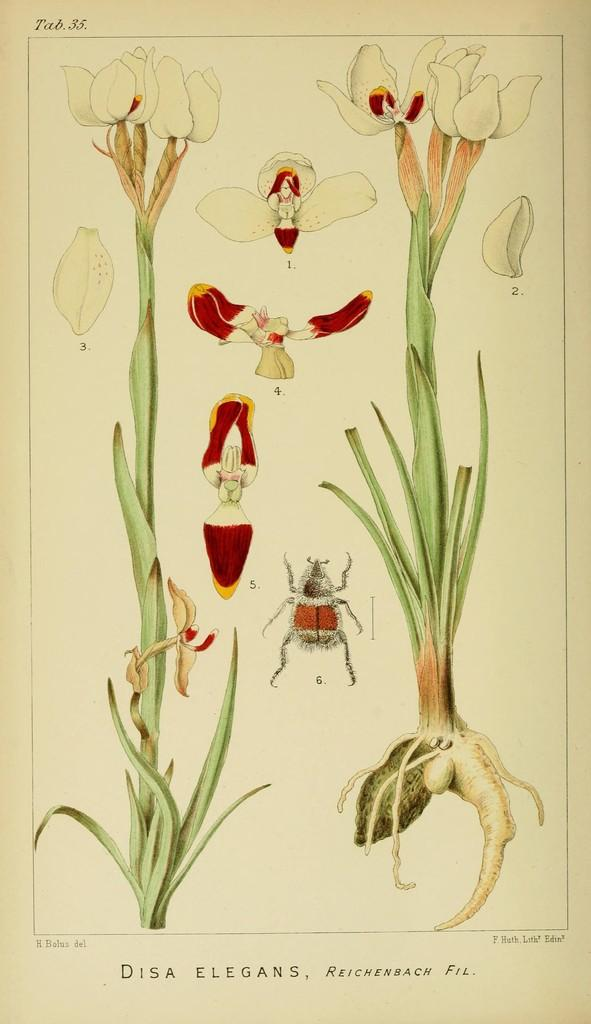What is the main subject of the image? The main subject of the image is a magazine poster. What other elements can be seen in the image besides the poster? There are plants with flowers and an insect in the image. Is there any text present in the image? Yes, there is text at the bottom of the image. What type of hair can be seen on the tramp in the image? There is no tramp or hair present in the image. 